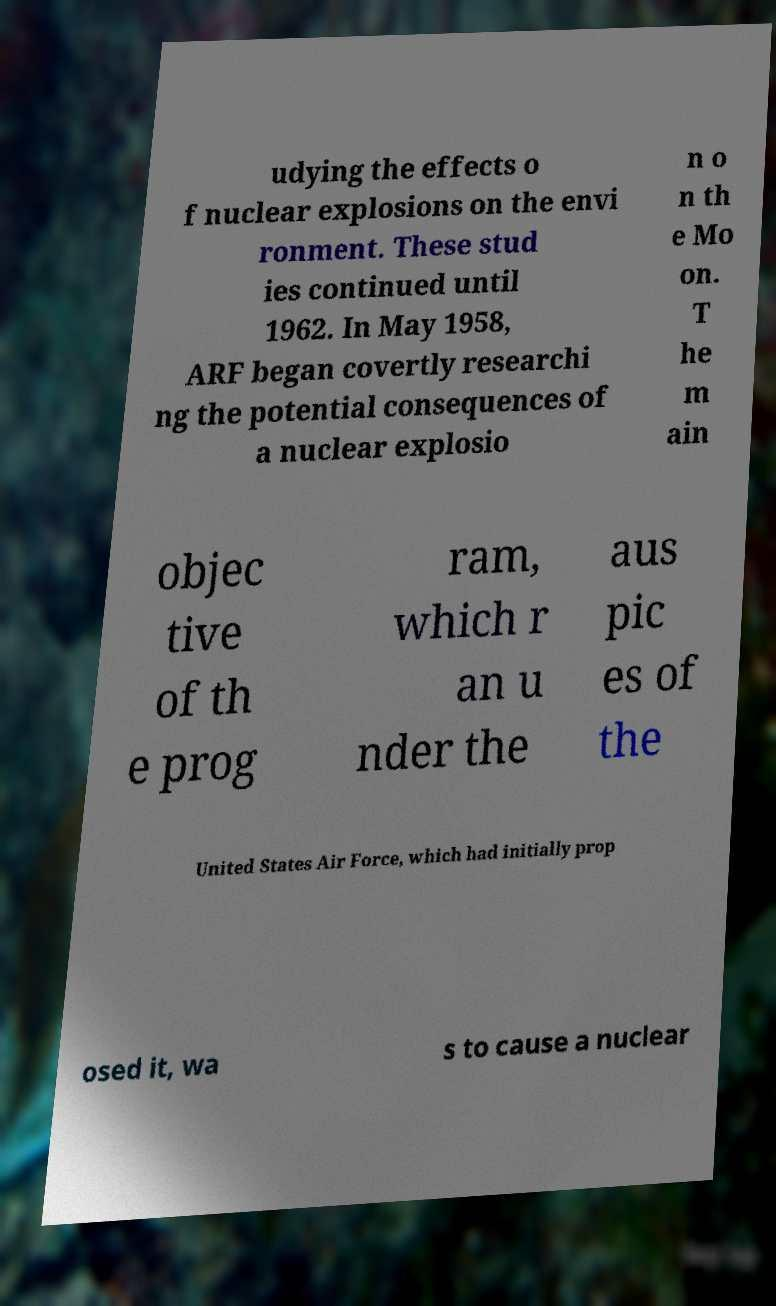Please identify and transcribe the text found in this image. udying the effects o f nuclear explosions on the envi ronment. These stud ies continued until 1962. In May 1958, ARF began covertly researchi ng the potential consequences of a nuclear explosio n o n th e Mo on. T he m ain objec tive of th e prog ram, which r an u nder the aus pic es of the United States Air Force, which had initially prop osed it, wa s to cause a nuclear 